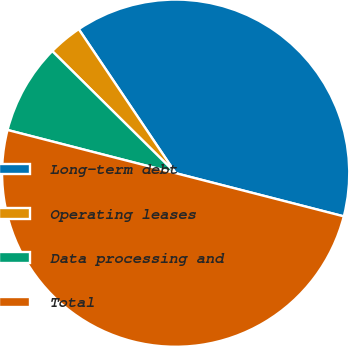<chart> <loc_0><loc_0><loc_500><loc_500><pie_chart><fcel>Long-term debt<fcel>Operating leases<fcel>Data processing and<fcel>Total<nl><fcel>38.43%<fcel>3.16%<fcel>8.41%<fcel>50.0%<nl></chart> 